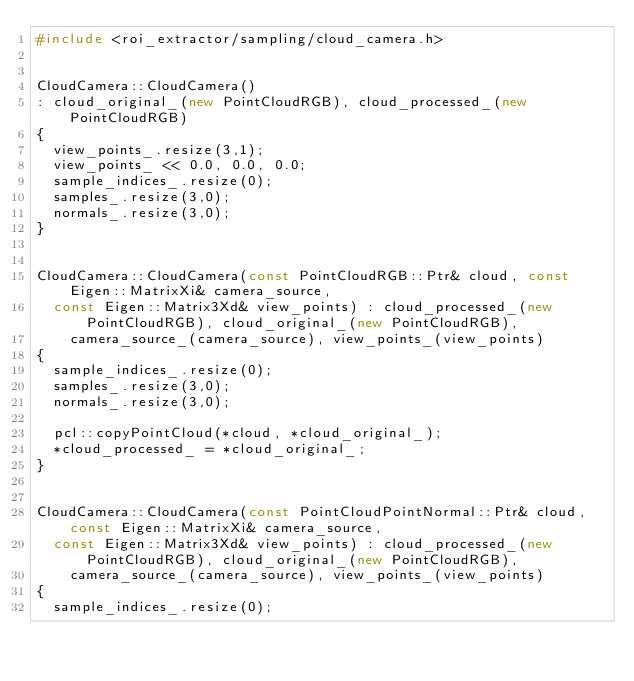Convert code to text. <code><loc_0><loc_0><loc_500><loc_500><_C++_>#include <roi_extractor/sampling/cloud_camera.h>


CloudCamera::CloudCamera()
: cloud_original_(new PointCloudRGB), cloud_processed_(new PointCloudRGB)
{
  view_points_.resize(3,1);
  view_points_ << 0.0, 0.0, 0.0;
  sample_indices_.resize(0);
  samples_.resize(3,0);
  normals_.resize(3,0);
}


CloudCamera::CloudCamera(const PointCloudRGB::Ptr& cloud, const Eigen::MatrixXi& camera_source,
  const Eigen::Matrix3Xd& view_points) : cloud_processed_(new PointCloudRGB), cloud_original_(new PointCloudRGB),
    camera_source_(camera_source), view_points_(view_points)
{
  sample_indices_.resize(0);
  samples_.resize(3,0);
  normals_.resize(3,0);

  pcl::copyPointCloud(*cloud, *cloud_original_);
  *cloud_processed_ = *cloud_original_;
}


CloudCamera::CloudCamera(const PointCloudPointNormal::Ptr& cloud, const Eigen::MatrixXi& camera_source,
  const Eigen::Matrix3Xd& view_points) : cloud_processed_(new PointCloudRGB), cloud_original_(new PointCloudRGB),
    camera_source_(camera_source), view_points_(view_points)
{
  sample_indices_.resize(0);</code> 